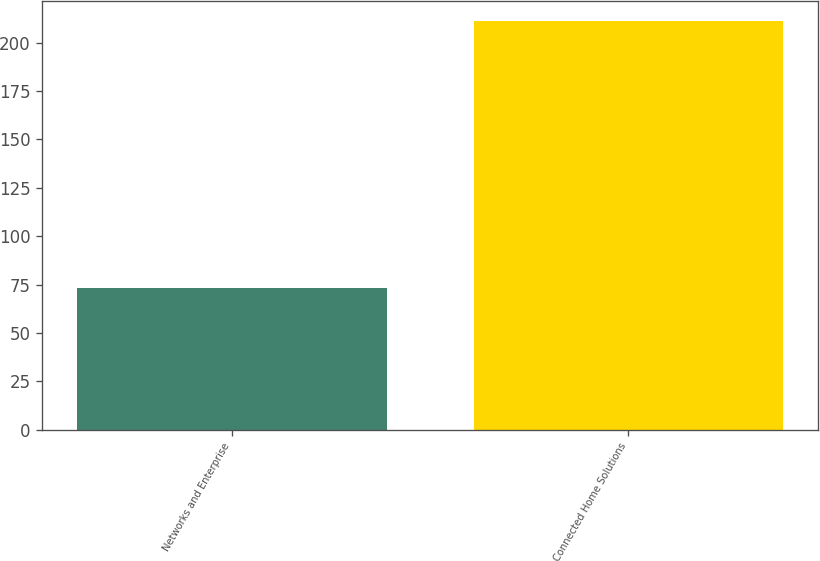Convert chart to OTSL. <chart><loc_0><loc_0><loc_500><loc_500><bar_chart><fcel>Networks and Enterprise<fcel>Connected Home Solutions<nl><fcel>73<fcel>211<nl></chart> 